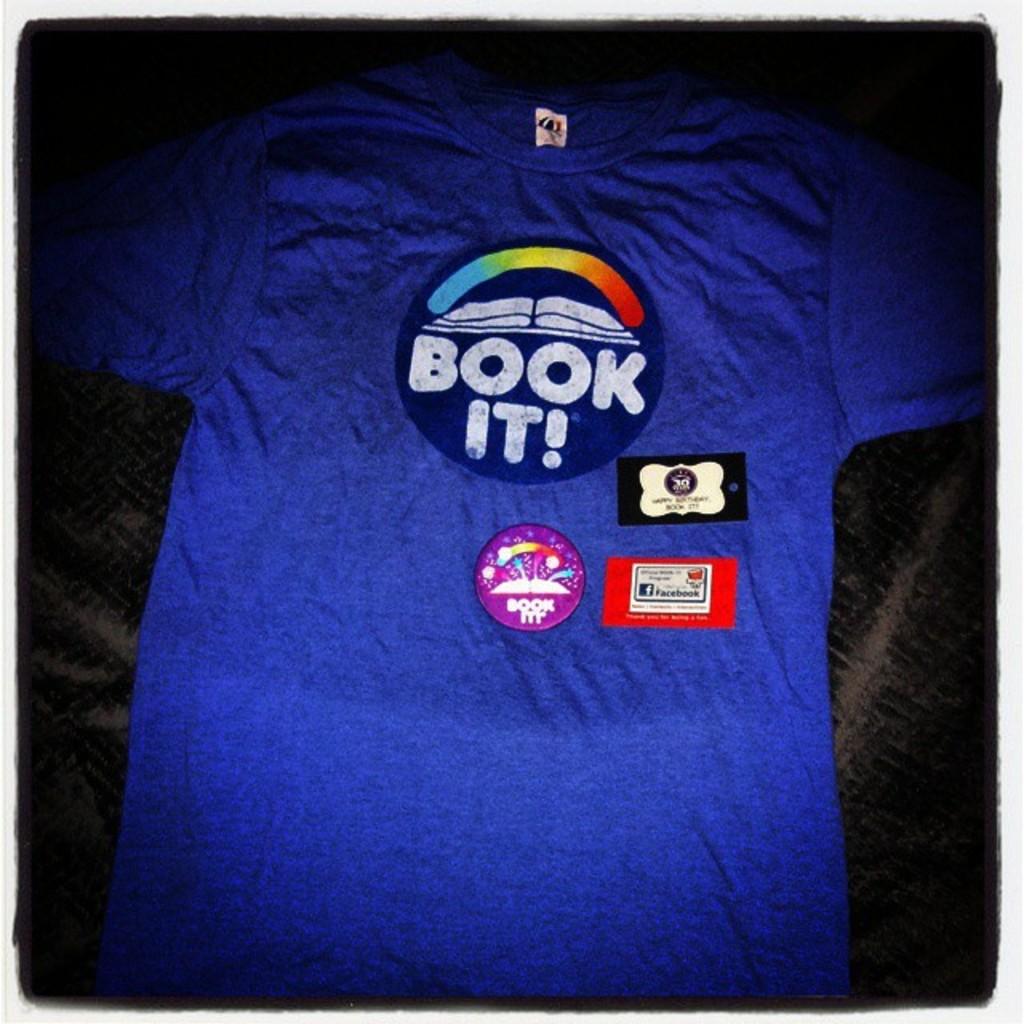What does the button say?
Your response must be concise. Book it. 